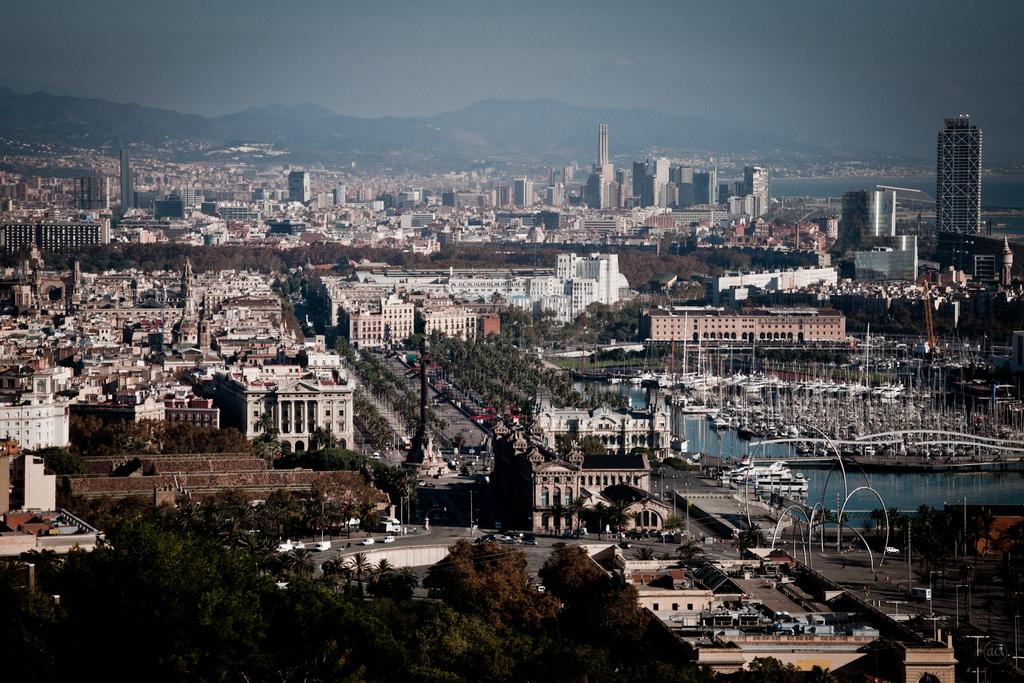What type of structures are present in the image? There are buildings in the image. What other natural elements can be seen in the image? There are trees in the image. What mode of transportation can be seen on the road in the image? There are vehicles on the road in the image. What is present on the water in the image? There are boats on the water in the image. What geographical feature is visible behind the buildings? There are hills visible behind the buildings. What part of the natural environment is visible in the image? The sky is visible in the image. What hobbies do the boys in the image enjoy? There are no boys present in the image, so their hobbies cannot be determined. How much sugar is present in the image? There is no reference to sugar in the image, so it cannot be determined how much sugar is present. 